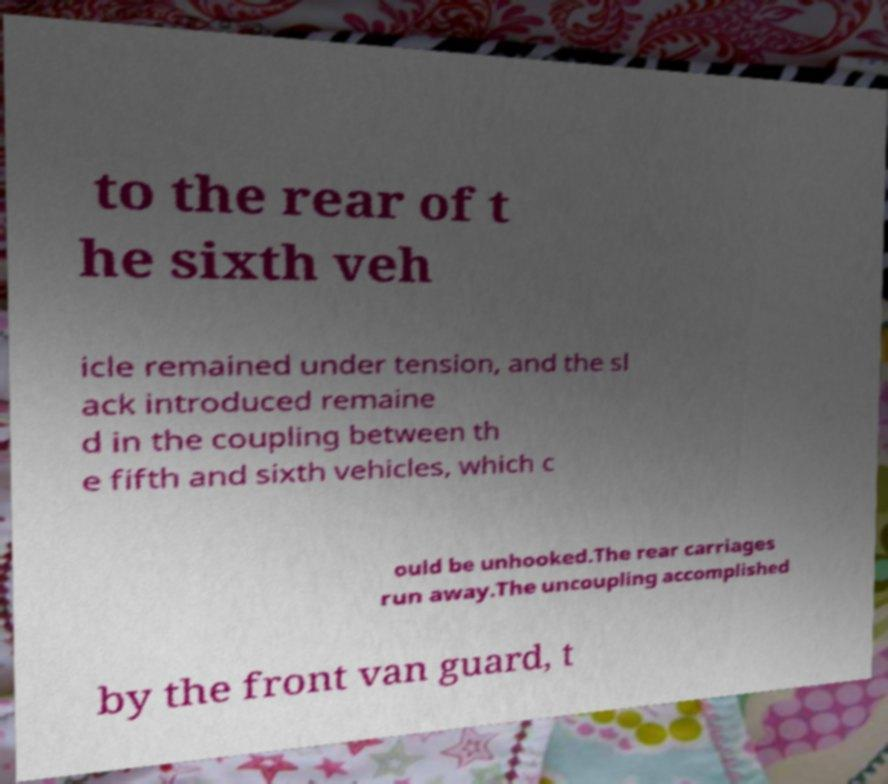I need the written content from this picture converted into text. Can you do that? to the rear of t he sixth veh icle remained under tension, and the sl ack introduced remaine d in the coupling between th e fifth and sixth vehicles, which c ould be unhooked.The rear carriages run away.The uncoupling accomplished by the front van guard, t 